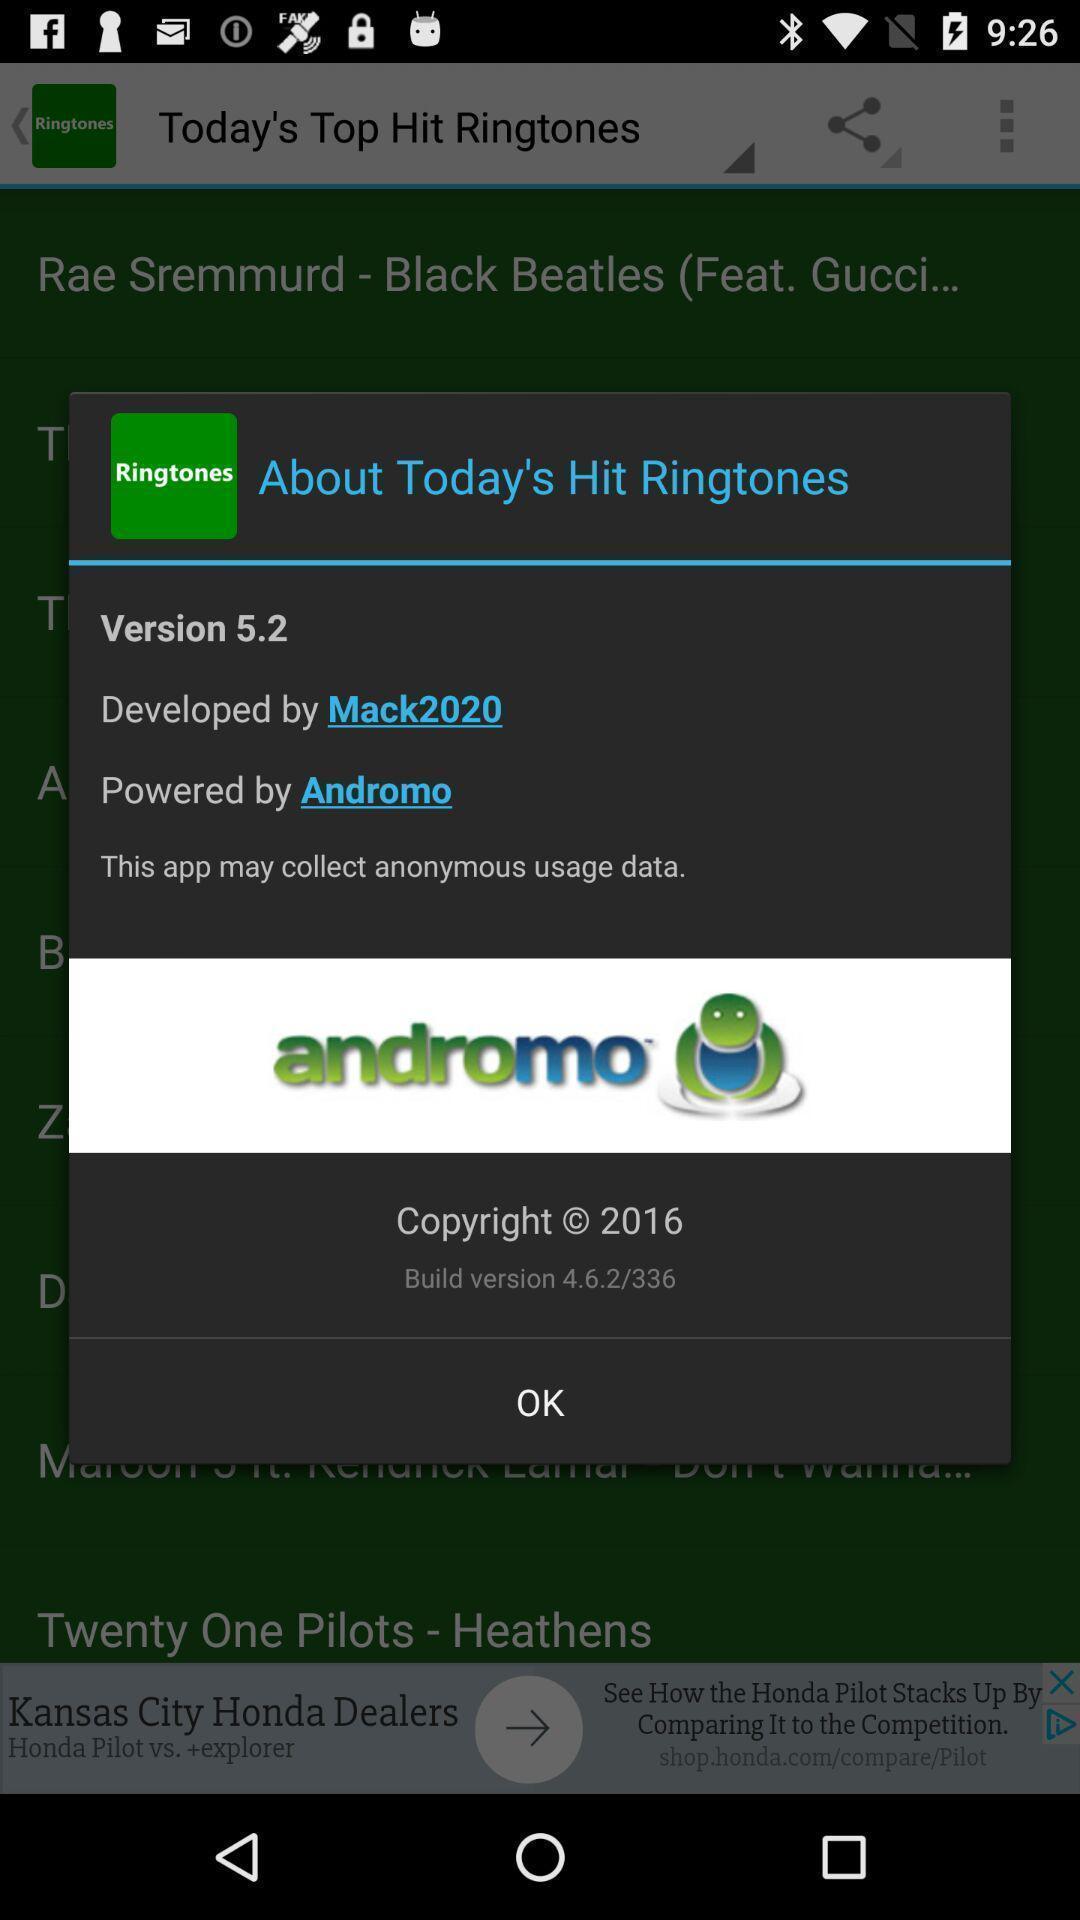Explain what's happening in this screen capture. Pop-up showing information about music application. 